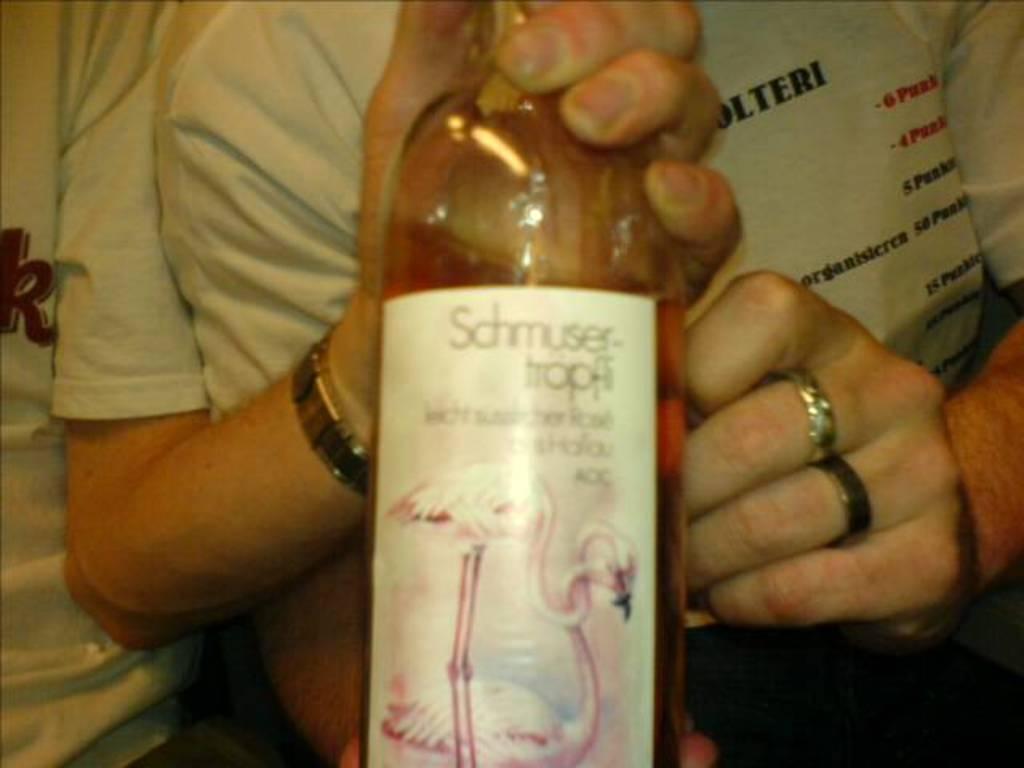In one or two sentences, can you explain what this image depicts? in the picture we can see two persons are standing together in which one person is holding a bottle in his hand. 